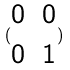Convert formula to latex. <formula><loc_0><loc_0><loc_500><loc_500>( \begin{matrix} 0 & 0 \\ 0 & 1 \end{matrix} )</formula> 